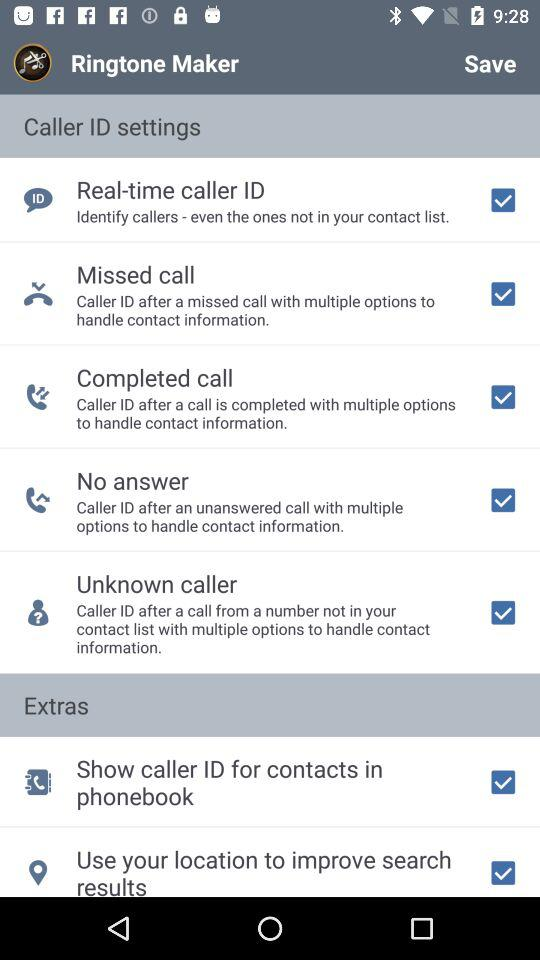How many caller ID settings are there?
Answer the question using a single word or phrase. 5 